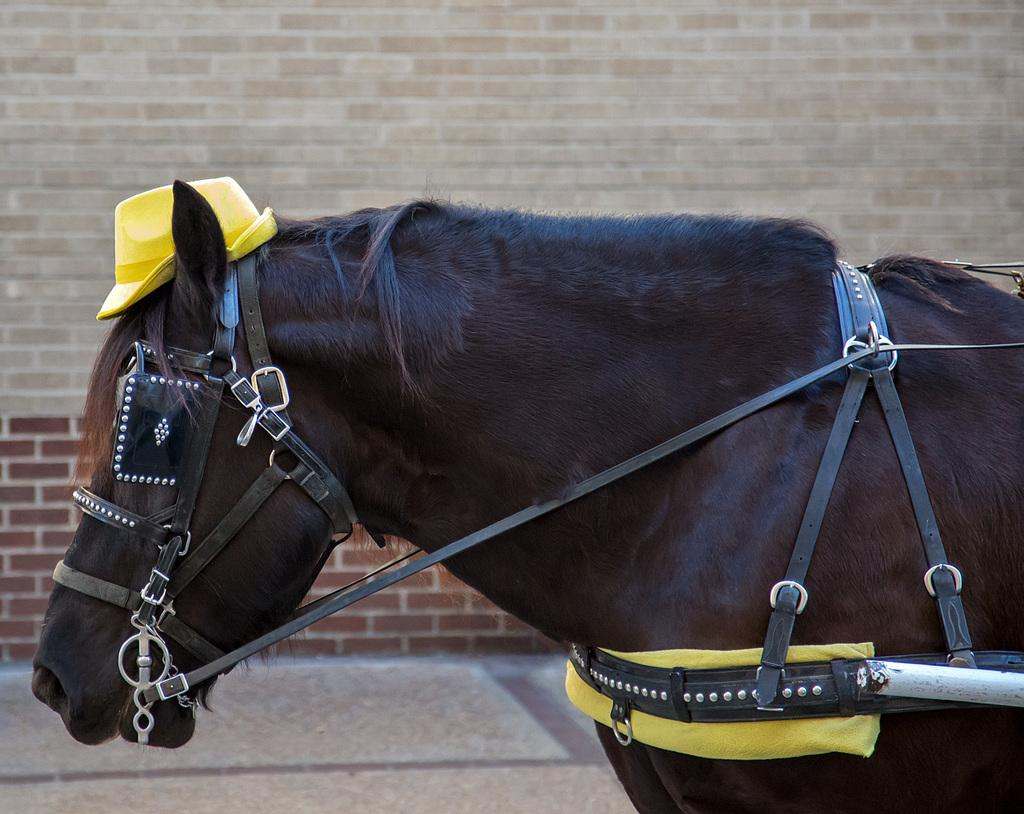What animal is present in the image? There is a horse in the image. What colors can be seen on the horse? The horse is black and brown in color. What accessories are on the horse? There are belts on the horse. What can be seen in the background of the image? There is a brick wall in the background of the image. How many silver bells are hanging from the scarecrow in the image? There is no scarecrow or silver bells present in the image; it features a horse with belts and a brick wall in the background. 